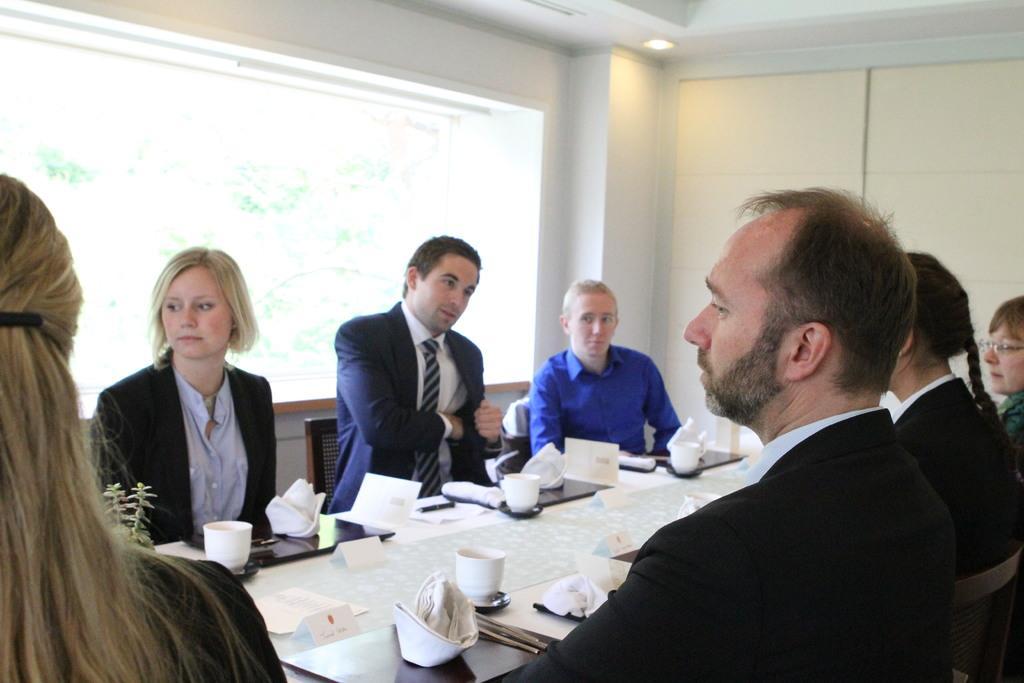How would you summarize this image in a sentence or two? In the image we can see there are people who are people who are sitting on chair and in front of them there is a table on which there are files and cups. 